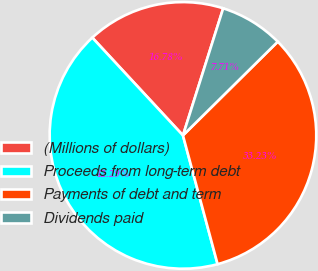Convert chart to OTSL. <chart><loc_0><loc_0><loc_500><loc_500><pie_chart><fcel>(Millions of dollars)<fcel>Proceeds from long-term debt<fcel>Payments of debt and term<fcel>Dividends paid<nl><fcel>16.78%<fcel>42.29%<fcel>33.23%<fcel>7.71%<nl></chart> 